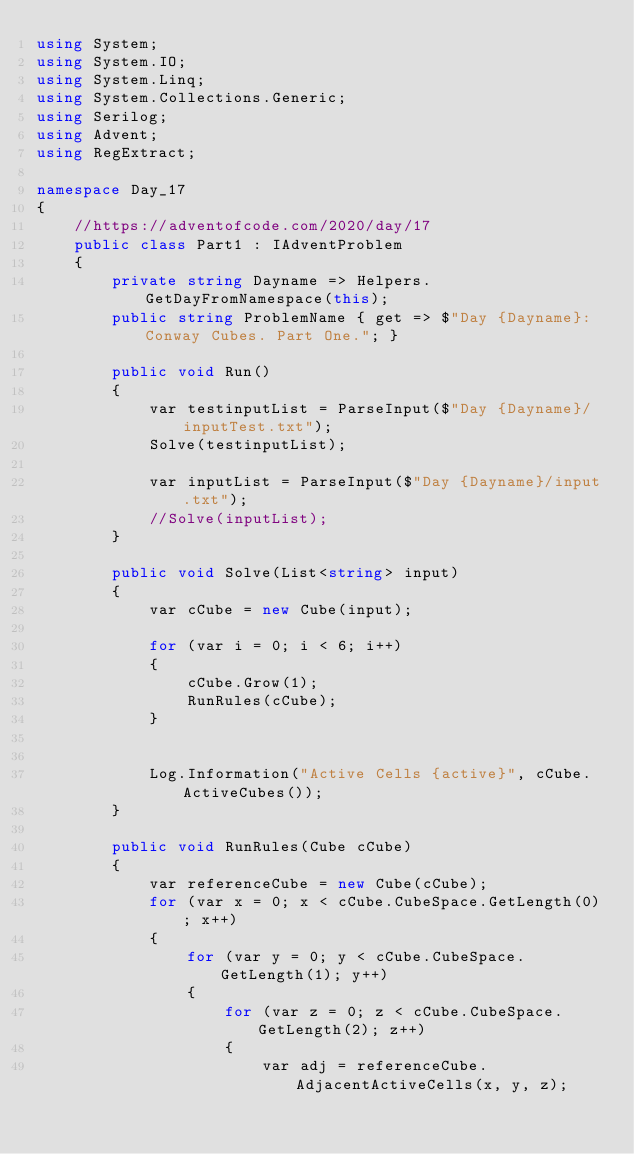Convert code to text. <code><loc_0><loc_0><loc_500><loc_500><_C#_>using System;
using System.IO;
using System.Linq;
using System.Collections.Generic;
using Serilog;
using Advent;
using RegExtract;

namespace Day_17
{
    //https://adventofcode.com/2020/day/17
    public class Part1 : IAdventProblem
    {
        private string Dayname => Helpers.GetDayFromNamespace(this);
        public string ProblemName { get => $"Day {Dayname}: Conway Cubes. Part One."; }

        public void Run()
        {
            var testinputList = ParseInput($"Day {Dayname}/inputTest.txt");
            Solve(testinputList);

            var inputList = ParseInput($"Day {Dayname}/input.txt");
            //Solve(inputList);
        }

        public void Solve(List<string> input)
        {
            var cCube = new Cube(input);

            for (var i = 0; i < 6; i++)
            {
                cCube.Grow(1);
                RunRules(cCube);
            }

            
            Log.Information("Active Cells {active}", cCube.ActiveCubes());
        }

        public void RunRules(Cube cCube)
        {
            var referenceCube = new Cube(cCube);
            for (var x = 0; x < cCube.CubeSpace.GetLength(0); x++)
            {
                for (var y = 0; y < cCube.CubeSpace.GetLength(1); y++)
                {
                    for (var z = 0; z < cCube.CubeSpace.GetLength(2); z++)
                    {
                        var adj = referenceCube.AdjacentActiveCells(x, y, z);</code> 